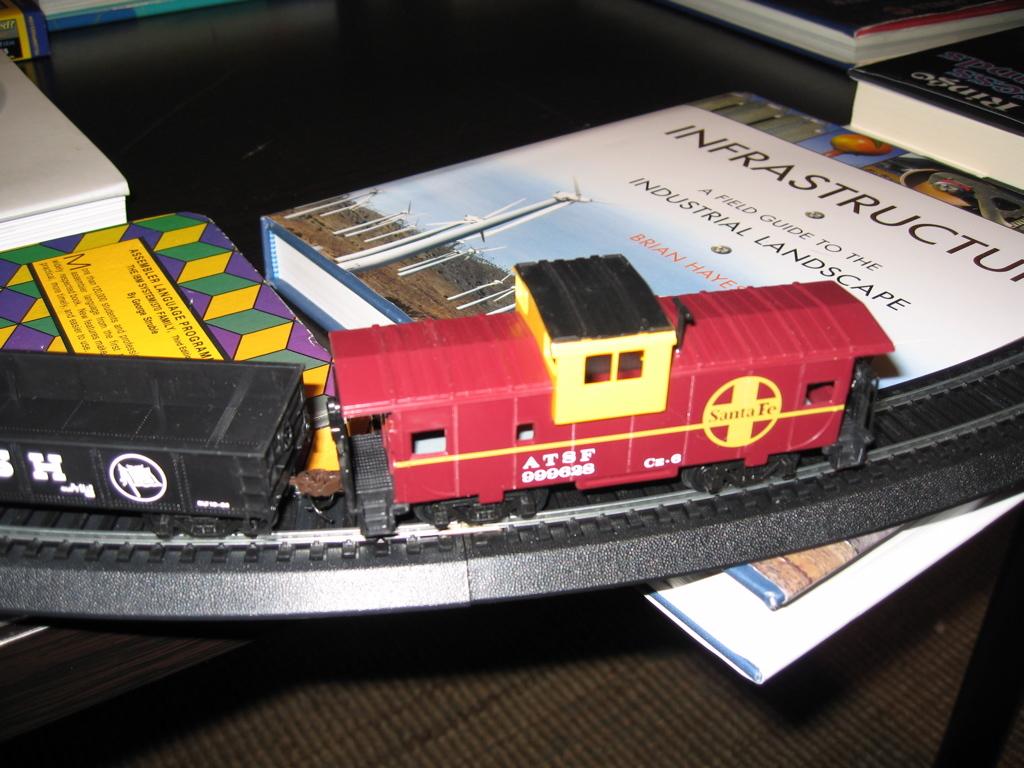What is the name on the book?
Offer a very short reply. Infrastructure. What kind of landscape?
Provide a short and direct response. Industrial. 